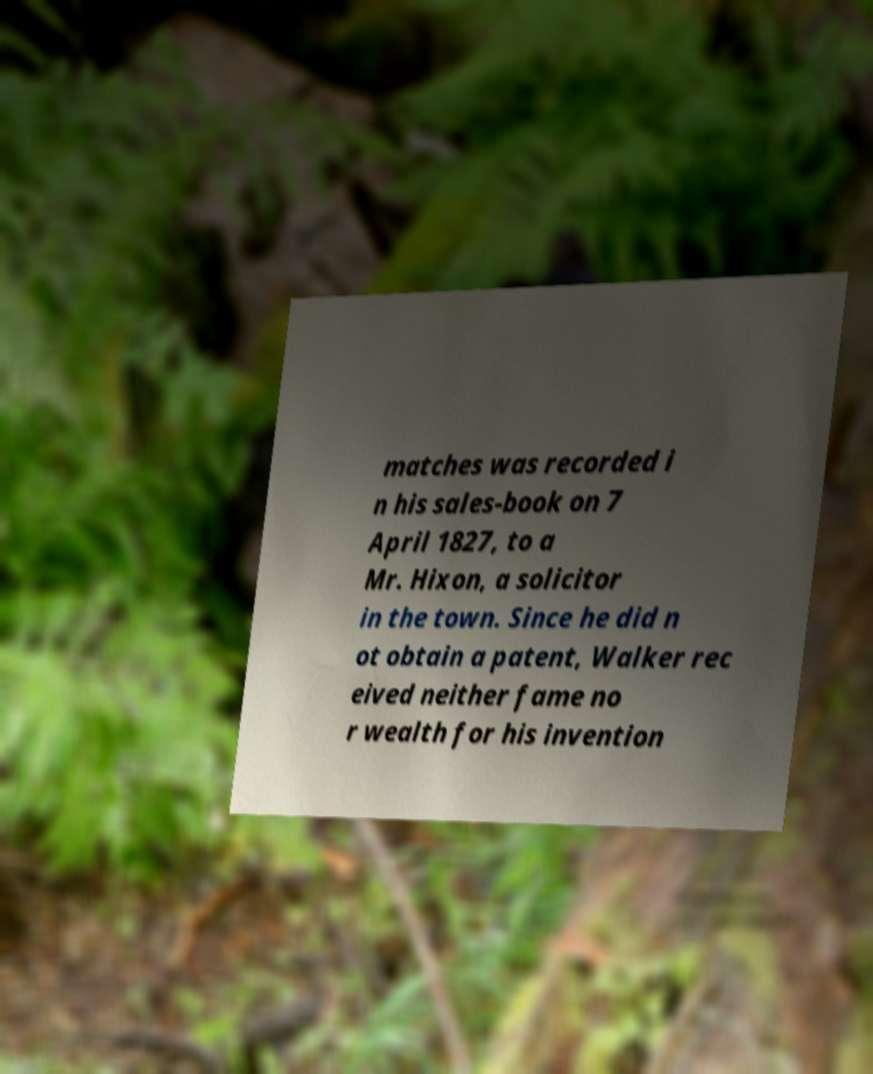Please read and relay the text visible in this image. What does it say? matches was recorded i n his sales-book on 7 April 1827, to a Mr. Hixon, a solicitor in the town. Since he did n ot obtain a patent, Walker rec eived neither fame no r wealth for his invention 